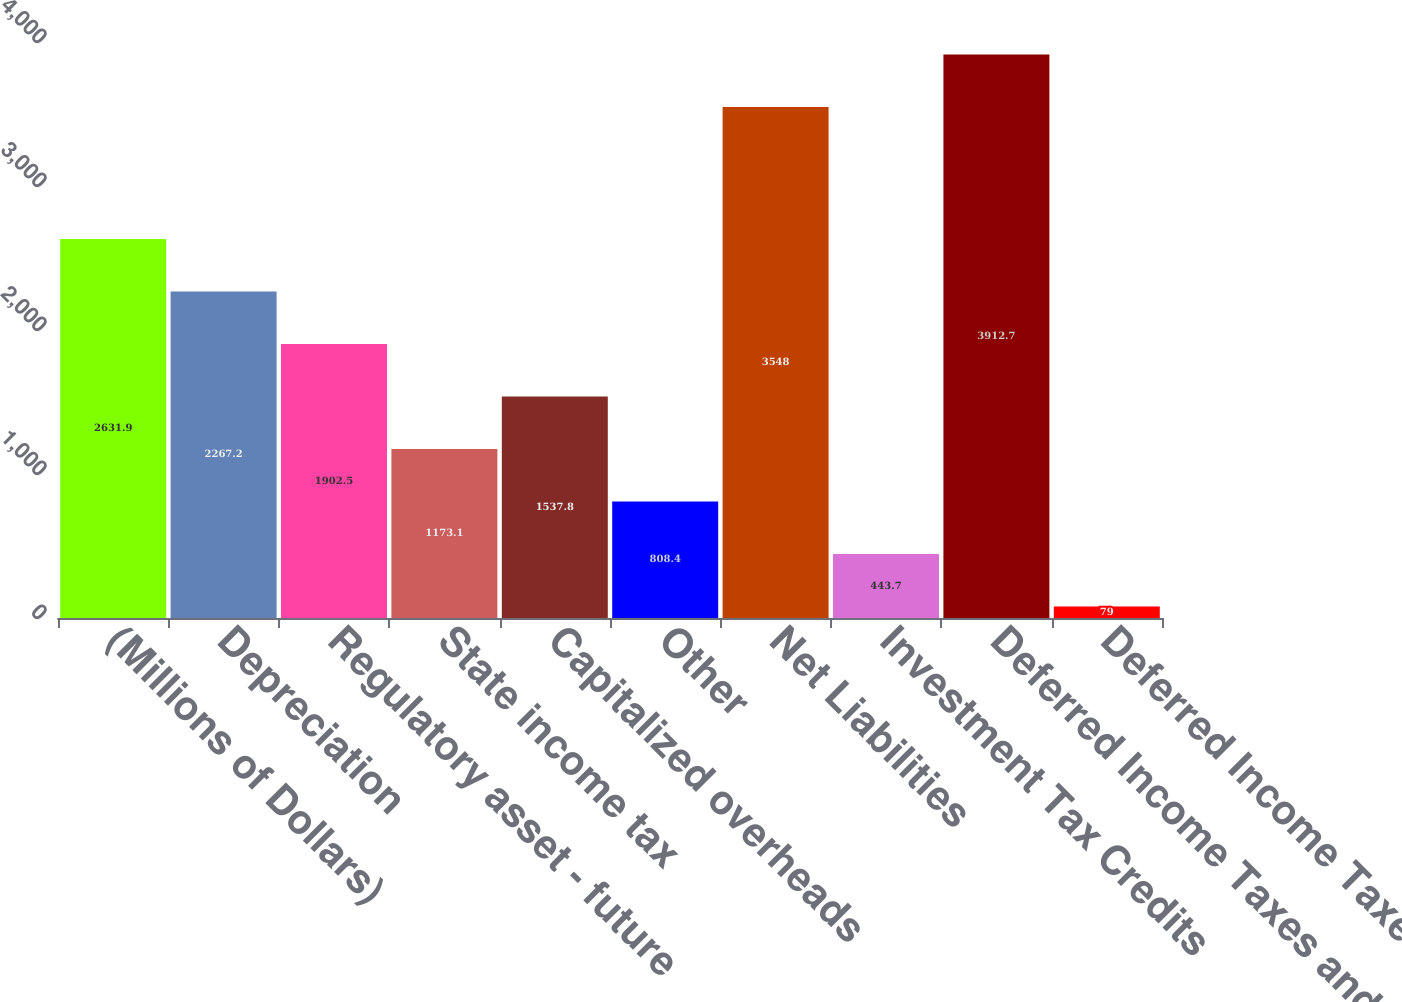<chart> <loc_0><loc_0><loc_500><loc_500><bar_chart><fcel>(Millions of Dollars)<fcel>Depreciation<fcel>Regulatory asset - future<fcel>State income tax<fcel>Capitalized overheads<fcel>Other<fcel>Net Liabilities<fcel>Investment Tax Credits<fcel>Deferred Income Taxes and<fcel>Deferred Income Taxes -<nl><fcel>2631.9<fcel>2267.2<fcel>1902.5<fcel>1173.1<fcel>1537.8<fcel>808.4<fcel>3548<fcel>443.7<fcel>3912.7<fcel>79<nl></chart> 